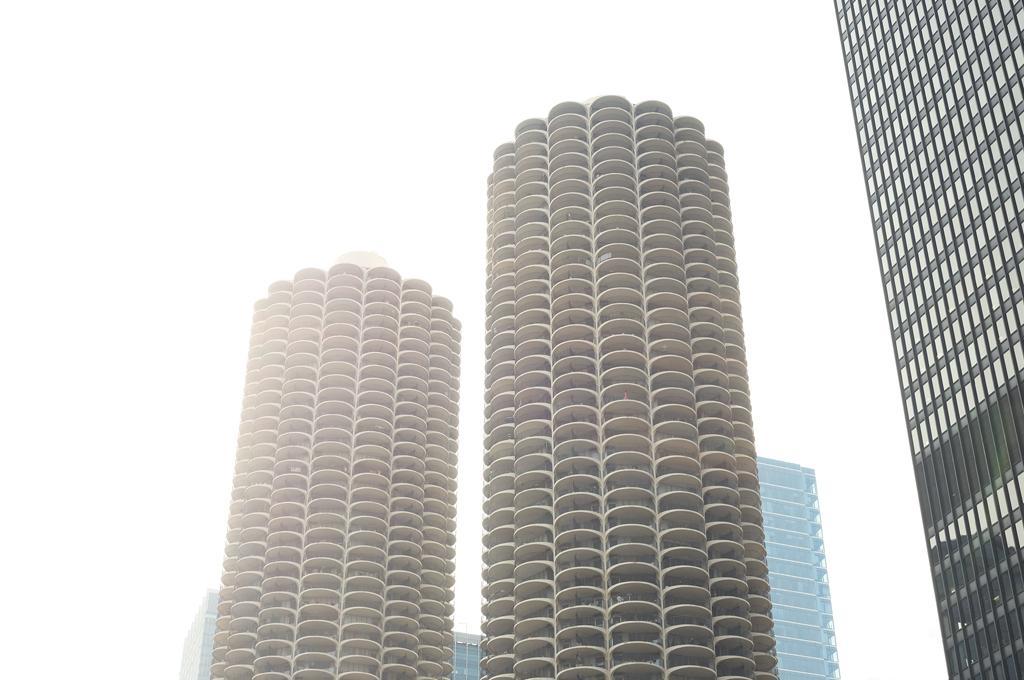In one or two sentences, can you explain what this image depicts? This image is taken outdoors. In this image there are two buildings and a few skyscrapers. 